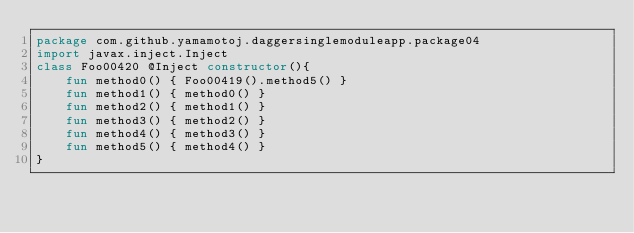<code> <loc_0><loc_0><loc_500><loc_500><_Kotlin_>package com.github.yamamotoj.daggersinglemoduleapp.package04
import javax.inject.Inject
class Foo00420 @Inject constructor(){
    fun method0() { Foo00419().method5() }
    fun method1() { method0() }
    fun method2() { method1() }
    fun method3() { method2() }
    fun method4() { method3() }
    fun method5() { method4() }
}
</code> 